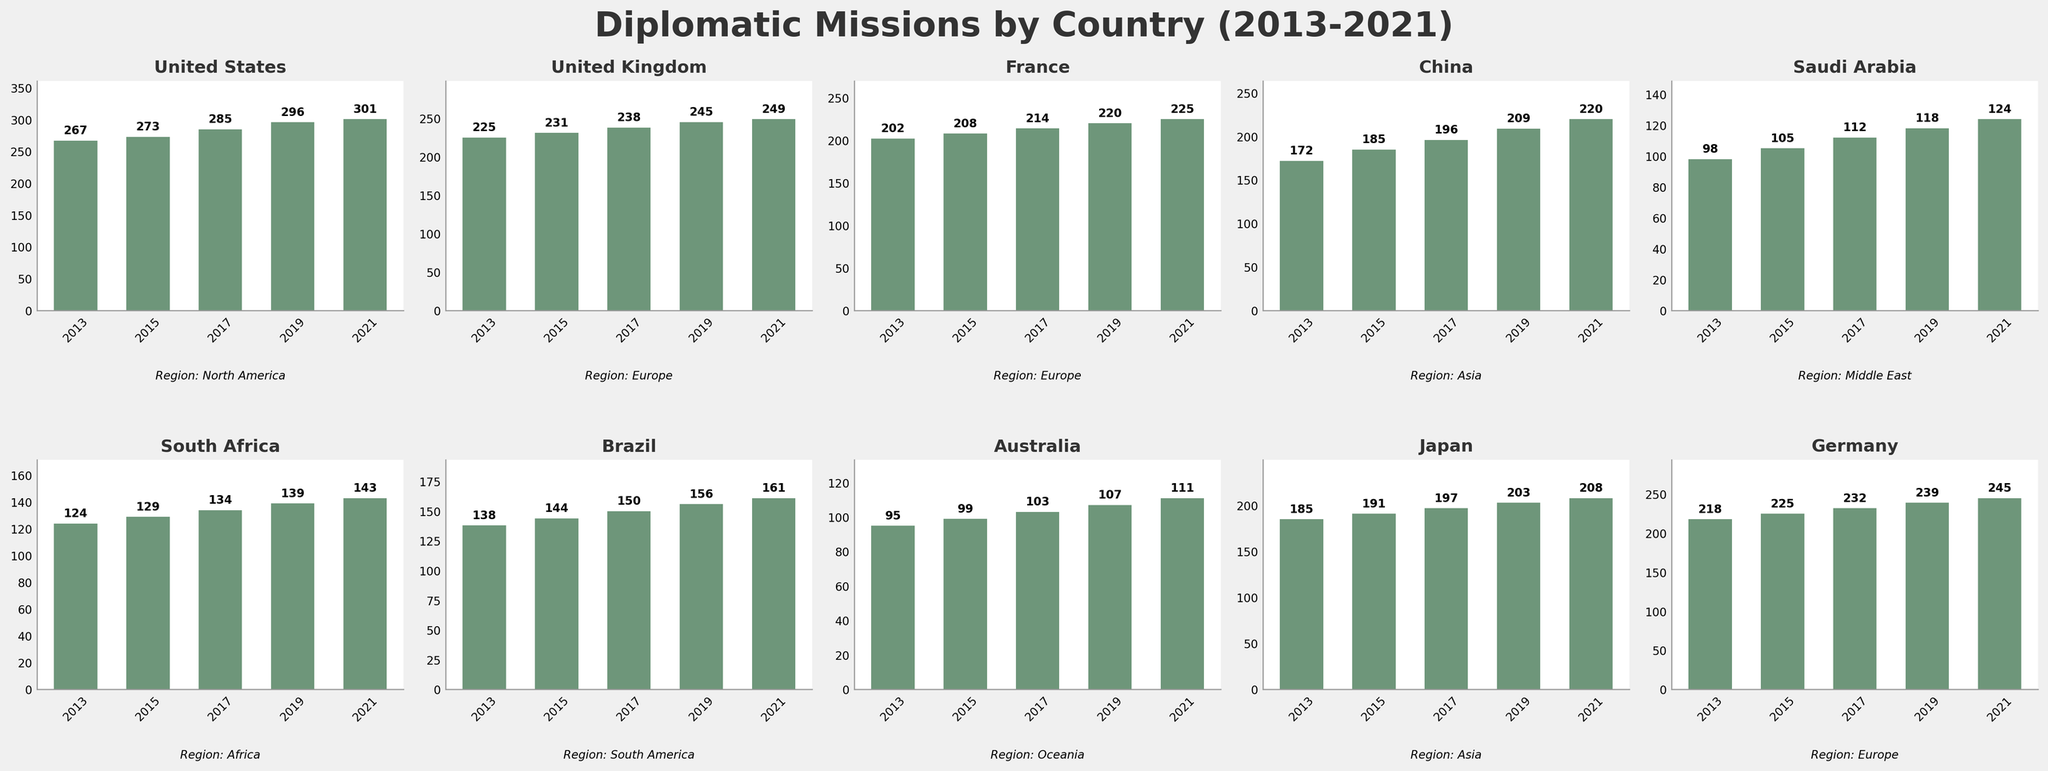Which country has the highest number of diplomatic missions in 2021? To determine the country with the highest number of diplomatic missions in 2021, analyze the bar corresponding to 2021 for each subplot. The United States has the tallest bar among all subplots for 2021.
Answer: United States Which region shows the highest growth in diplomatic missions from 2013 to 2021? Compare the difference between the 2013 and 2021 values for all countries and then identify which region has the largest difference. The United States in North America shows the highest growth (301 - 267 = 34).
Answer: North America What is the average number of diplomatic missions for France from 2013 to 2021? Sum up all the diplomatic mission numbers for France from 2013 to 2021 (202 + 208 + 214 + 220 + 225) and then divide by the number of years (5). The result is 1069 / 5 = 213.8.
Answer: 213.8 Which country in Europe had the least increase in diplomatic missions from 2013 to 2021? Look at the difference between 2013 and 2021 for each European country. France has the least increase (225 - 202 = 23).
Answer: France How many diplomatic missions did Japan have in total across all years presented? Add up the number of diplomatic missions for Japan from 2013 to 2021 (185 + 191 + 197 + 203 + 208). The result is 984.
Answer: 984 Which year shows the most consistent number of diplomatic missions across all countries? Observe the height of the bars for each year across all subplots. The year with the least variation in bar heights is generally 2021 as all have shown a gradual increase over the decade but convergence in 2021.
Answer: 2021 Is the trend in the number of diplomatic missions for China increasing or decreasing? By examining each of the bars for China from 2013 to 2021, it clearly shows an upward trend (172, 185, 196, 209, 220).
Answer: Increasing Which country in Asia has a lower number of diplomatic missions in 2013 than Japan? Compare the 2013 bars for China and Japan. China has fewer diplomatic missions in 2013 (172 vs. 185).
Answer: China Between the United Kingdom and Germany, which country had a higher number of diplomatic missions in 2017? Compare the heights of the bars for 2017 in the subplots for the United Kingdom and Germany. Germany had higher missions in 2017 (232 vs. 238).
Answer: Germany What is the difference in the number of diplomatic missions between Saudi Arabia and Australia in 2021? Subtract the 2021 value of Australia from that of Saudi Arabia (124 - 111 = 13).
Answer: 13 